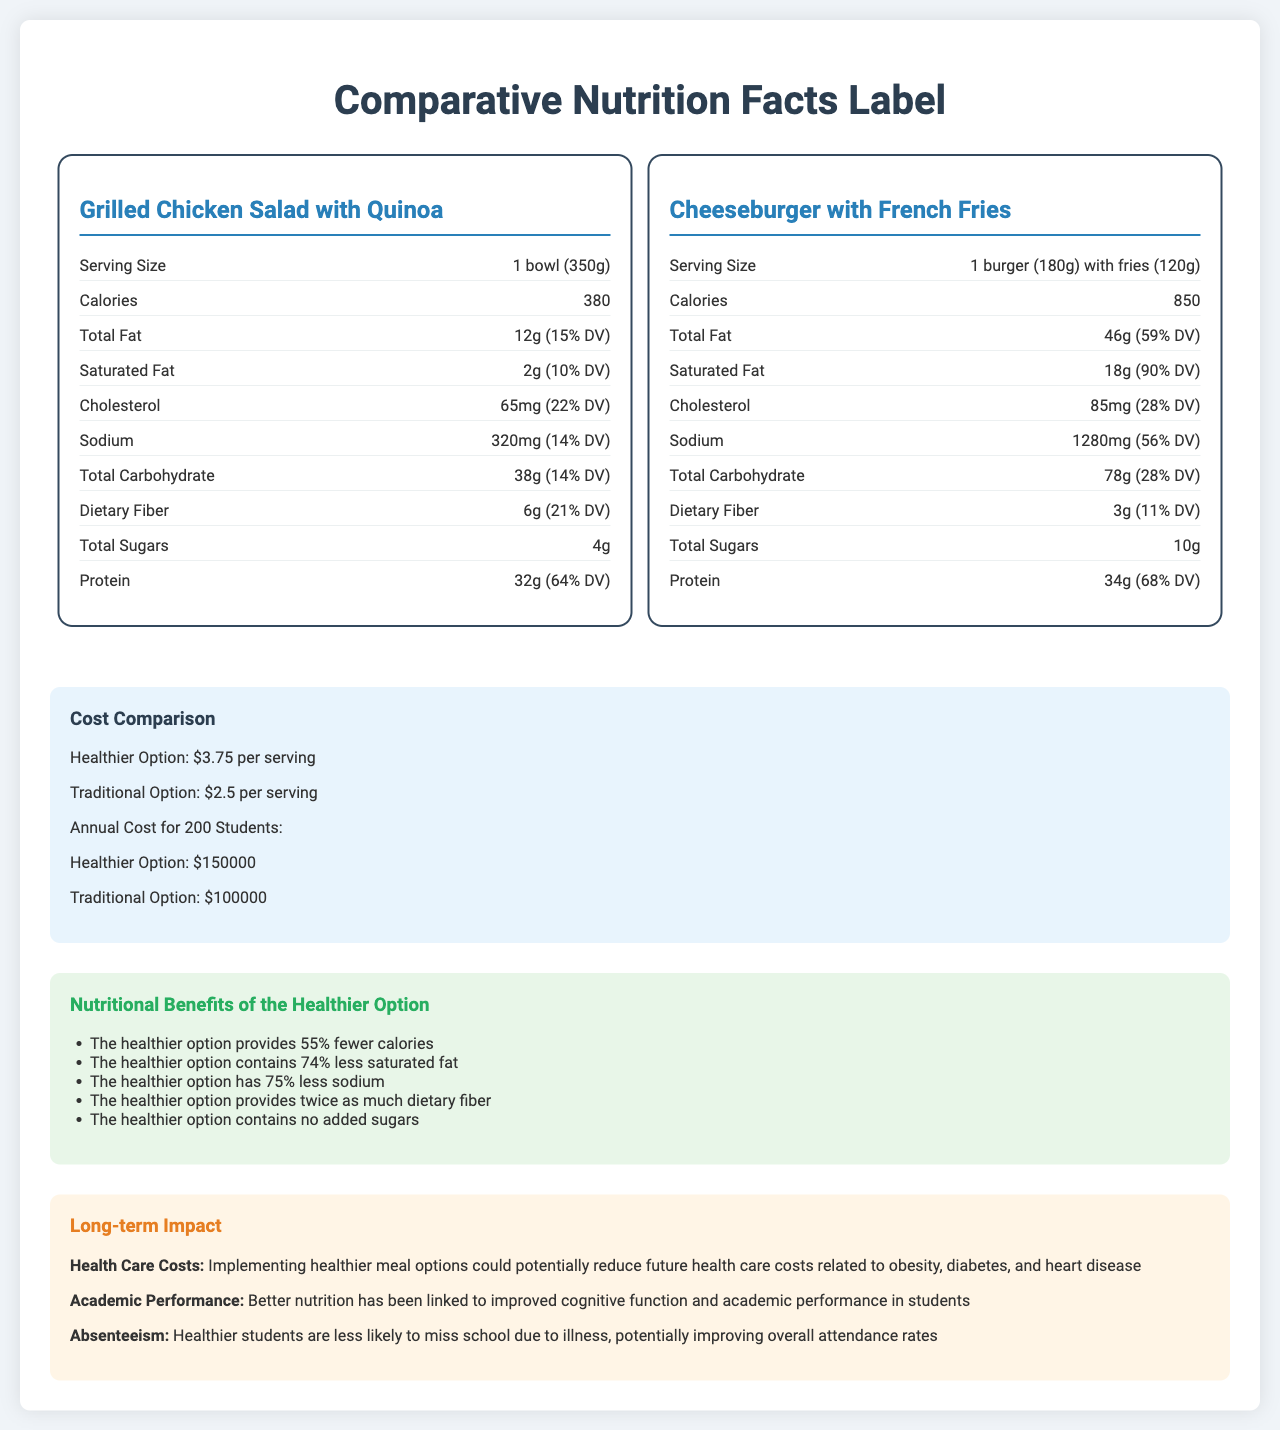what is the calorie difference between the healthier option and the traditional option? The healthier option has 380 calories, and the traditional option has 850 calories. The difference is 470 calories.
Answer: 470 calories what is the serving size for the healthier meal option? The serving size for the healthier meal option, Grilled Chicken Salad with Quinoa, is 1 bowl (350g).
Answer: 1 bowl (350g) Which meal option contains more total fat? A. Healthier Option B. Traditional Option The healthier option contains 12g of total fat, while the traditional option contains 46g of total fat.
Answer: B how much dietary fiber does the traditional option contain? The traditional option, Cheeseburger with French Fries, contains 3g of dietary fiber.
Answer: 3g What is the daily value of protein for the healthier option? The document shows that the healthier option provides 32g of protein with a daily value percentage of 64%.
Answer: 64% is the healthier option free of trans fats? The healthier option has 0g of trans fat.
Answer: Yes Which meal option has a higher cholesterol content? A. Healthier Option B. Traditional Option The healthier option has 65mg of cholesterol, while the traditional option has 85mg of cholesterol.
Answer: B what are some long-term benefits of implementing healthier meal options? The document lists several long-term impacts such as reduced health care costs related to obesity, diabetes, and heart disease, improved cognitive function and academic performance, and better attendance rates due to reduced illness.
Answer: Reduced future health care costs, improved cognitive function and academic performance, improved attendance rates How much sodium does the traditional option contain? The traditional option contains 1280mg of sodium.
Answer: 1280mg Compare the costs of the annual budget for 200 students for the healthier and traditional options. The document states the annual cost for 200 students: $150,000 for the healthier option and $100,000 for the traditional option.
Answer: The healthier option costs $150,000, while the traditional option costs $100,000 annually. Does the healthier option contain any added sugars? The healthier option contains 0g of added sugars.
Answer: No Which option has a higher percentage of daily value of iron? A. Healthier Option B. Traditional Option C. Both have the same percentage The healthier option provides 14% DV of iron, while the traditional option provides 27% DV of iron.
Answer: B What is the main idea of this document? This document illustrates the differences between a healthier school meal option and a traditional one in terms of nutrition, costs, and potential benefits and challenges. It outlines the nutritional content, the costs involved, and the long-term impacts on health, academic performance, and attendance rates.
Answer: The document compares the nutritional and economic aspects of a healthier meal option against a traditional meal option for school students, highlighting nutritional benefits, costs, long-term impacts, and implementation challenges of opting for healthier meals. What is the total cost per serving of the healthier option? The document specifies that the healthier option costs $3.75 per serving.
Answer: $3.75 What types of funding sources are suggested for implementing healthier meals? The document lists potential funding sources including USDA's National School Lunch Program, state-level healthy school meal initiatives, private sector partnerships with health-focused organizations, and grants from nutrition and wellness foundations.
Answer: USDA's National School Lunch Program, state-level initiatives, private sector partnerships, grants from nutrition and wellness foundations How is the percentage of daily value for potassium different between the two options? The healthier option provides 720mg of potassium (15% DV), and the traditional option provides 640mg of potassium (14% DV).
Answer: The healthier option has a 15% DV for potassium; the traditional option has a 14% DV for potassium. What is the actual serving size for the traditional option? The document states that the serving size for the traditional option is 1 burger (180g) with fries (120g).
Answer: 1 burger (180g) with fries (120g) What are some implementation challenges for adding healthier meal options? The document lists several challenges: higher cost of healthier ingredients, potential resistance from students accustomed to traditional options, need for additional staff training in preparing healthier meals, and possible equipment upgrades for food preparation and storage.
Answer: The higher cost of healthier ingredients, potential resistance from students, need for additional staff training, possible equipment upgrades How much vitamin D does the healthier meal contain? The document states that the healthier meal option does not contain any vitamin D (0 mcg).
Answer: 0 mcg How many types of funding sources are mentioned in the document? The document mentions various funding sources but does not provide a specific count for how many different types are listed.
Answer: Not enough information 